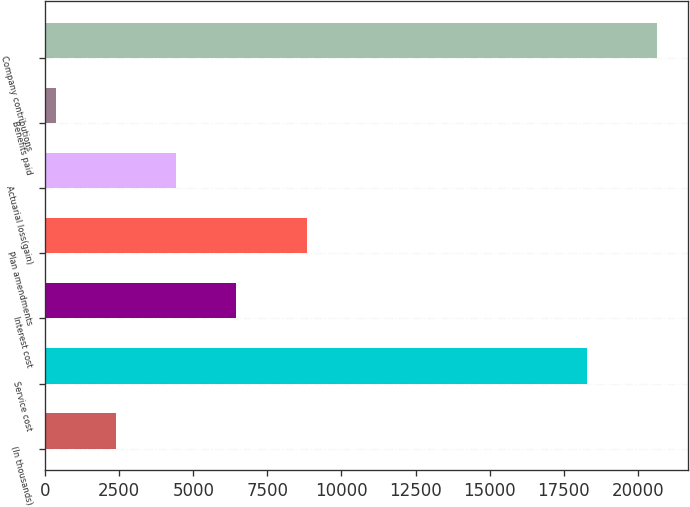Convert chart to OTSL. <chart><loc_0><loc_0><loc_500><loc_500><bar_chart><fcel>(In thousands)<fcel>Service cost<fcel>Interest cost<fcel>Plan amendments<fcel>Actuarial loss(gain)<fcel>Benefits paid<fcel>Company contributions<nl><fcel>2393.9<fcel>18291<fcel>6451.7<fcel>8834<fcel>4422.8<fcel>365<fcel>20654<nl></chart> 